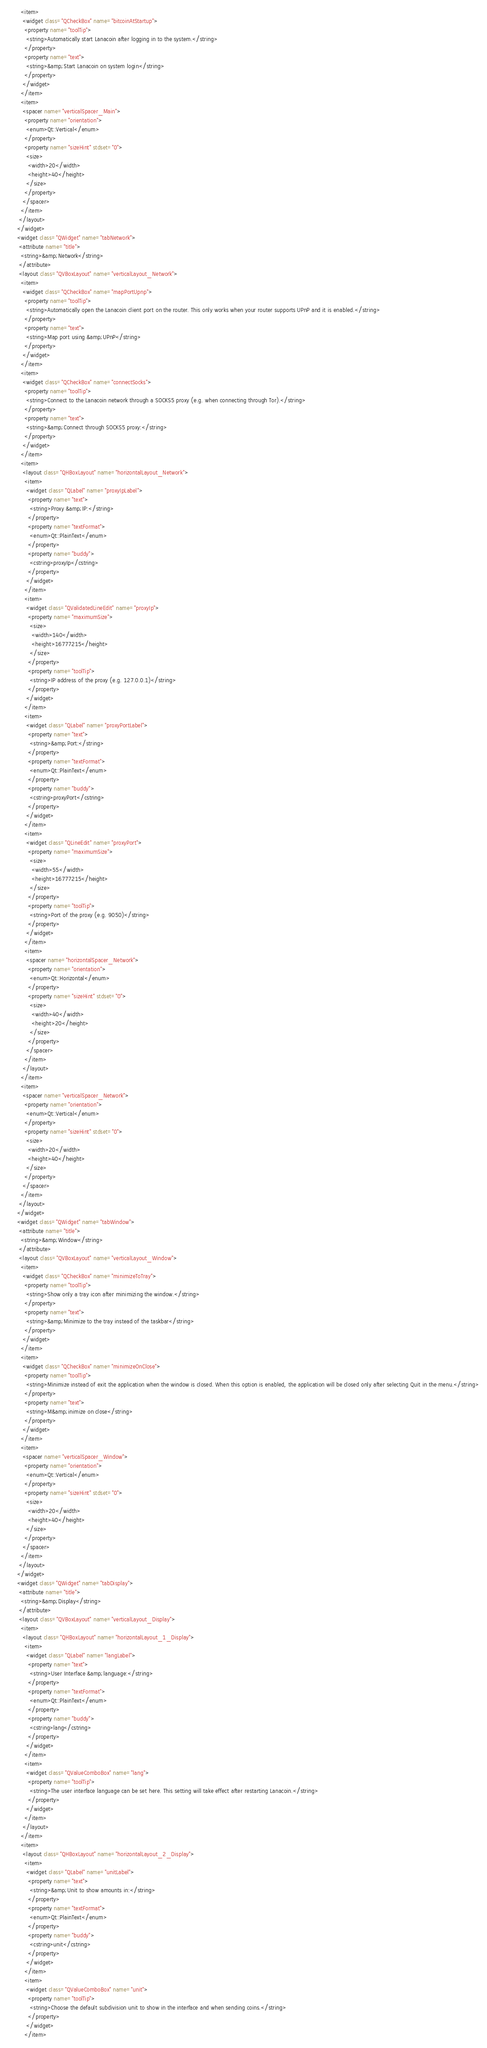<code> <loc_0><loc_0><loc_500><loc_500><_XML_>       <item>
        <widget class="QCheckBox" name="bitcoinAtStartup">
         <property name="toolTip">
          <string>Automatically start Lanacoin after logging in to the system.</string>
         </property>
         <property name="text">
          <string>&amp;Start Lanacoin on system login</string>
         </property>
        </widget>
       </item>
       <item>
        <spacer name="verticalSpacer_Main">
         <property name="orientation">
          <enum>Qt::Vertical</enum>
         </property>
         <property name="sizeHint" stdset="0">
          <size>
           <width>20</width>
           <height>40</height>
          </size>
         </property>
        </spacer>
       </item>
      </layout>
     </widget>
     <widget class="QWidget" name="tabNetwork">
      <attribute name="title">
       <string>&amp;Network</string>
      </attribute>
      <layout class="QVBoxLayout" name="verticalLayout_Network">
       <item>
        <widget class="QCheckBox" name="mapPortUpnp">
         <property name="toolTip">
          <string>Automatically open the Lanacoin client port on the router. This only works when your router supports UPnP and it is enabled.</string>
         </property>
         <property name="text">
          <string>Map port using &amp;UPnP</string>
         </property>
        </widget>
       </item>
       <item>
        <widget class="QCheckBox" name="connectSocks">
         <property name="toolTip">
          <string>Connect to the Lanacoin network through a SOCKS5 proxy (e.g. when connecting through Tor).</string>
         </property>
         <property name="text">
          <string>&amp;Connect through SOCKS5 proxy:</string>
         </property>
        </widget>
       </item>
       <item>
        <layout class="QHBoxLayout" name="horizontalLayout_Network">
         <item>
          <widget class="QLabel" name="proxyIpLabel">
           <property name="text">
            <string>Proxy &amp;IP:</string>
           </property>
           <property name="textFormat">
            <enum>Qt::PlainText</enum>
           </property>
           <property name="buddy">
            <cstring>proxyIp</cstring>
           </property>
          </widget>
         </item>
         <item>
          <widget class="QValidatedLineEdit" name="proxyIp">
           <property name="maximumSize">
            <size>
             <width>140</width>
             <height>16777215</height>
            </size>
           </property>
           <property name="toolTip">
            <string>IP address of the proxy (e.g. 127.0.0.1)</string>
           </property>
          </widget>
         </item>
         <item>
          <widget class="QLabel" name="proxyPortLabel">
           <property name="text">
            <string>&amp;Port:</string>
           </property>
           <property name="textFormat">
            <enum>Qt::PlainText</enum>
           </property>
           <property name="buddy">
            <cstring>proxyPort</cstring>
           </property>
          </widget>
         </item>
         <item>
          <widget class="QLineEdit" name="proxyPort">
           <property name="maximumSize">
            <size>
             <width>55</width>
             <height>16777215</height>
            </size>
           </property>
           <property name="toolTip">
            <string>Port of the proxy (e.g. 9050)</string>
           </property>
          </widget>
         </item>
         <item>
          <spacer name="horizontalSpacer_Network">
           <property name="orientation">
            <enum>Qt::Horizontal</enum>
           </property>
           <property name="sizeHint" stdset="0">
            <size>
             <width>40</width>
             <height>20</height>
            </size>
           </property>
          </spacer>
         </item>
        </layout>
       </item>
       <item>
        <spacer name="verticalSpacer_Network">
         <property name="orientation">
          <enum>Qt::Vertical</enum>
         </property>
         <property name="sizeHint" stdset="0">
          <size>
           <width>20</width>
           <height>40</height>
          </size>
         </property>
        </spacer>
       </item>
      </layout>
     </widget>
     <widget class="QWidget" name="tabWindow">
      <attribute name="title">
       <string>&amp;Window</string>
      </attribute>
      <layout class="QVBoxLayout" name="verticalLayout_Window">
       <item>
        <widget class="QCheckBox" name="minimizeToTray">
         <property name="toolTip">
          <string>Show only a tray icon after minimizing the window.</string>
         </property>
         <property name="text">
          <string>&amp;Minimize to the tray instead of the taskbar</string>
         </property>
        </widget>
       </item>
       <item>
        <widget class="QCheckBox" name="minimizeOnClose">
         <property name="toolTip">
          <string>Minimize instead of exit the application when the window is closed. When this option is enabled, the application will be closed only after selecting Quit in the menu.</string>
         </property>
         <property name="text">
          <string>M&amp;inimize on close</string>
         </property>
        </widget>
       </item>
       <item>
        <spacer name="verticalSpacer_Window">
         <property name="orientation">
          <enum>Qt::Vertical</enum>
         </property>
         <property name="sizeHint" stdset="0">
          <size>
           <width>20</width>
           <height>40</height>
          </size>
         </property>
        </spacer>
       </item>
      </layout>
     </widget>
     <widget class="QWidget" name="tabDisplay">
      <attribute name="title">
       <string>&amp;Display</string>
      </attribute>
      <layout class="QVBoxLayout" name="verticalLayout_Display">
       <item>
        <layout class="QHBoxLayout" name="horizontalLayout_1_Display">
         <item>
          <widget class="QLabel" name="langLabel">
           <property name="text">
            <string>User Interface &amp;language:</string>
           </property>
           <property name="textFormat">
            <enum>Qt::PlainText</enum>
           </property>
           <property name="buddy">
            <cstring>lang</cstring>
           </property>
          </widget>
         </item>
         <item>
          <widget class="QValueComboBox" name="lang">
           <property name="toolTip">
            <string>The user interface language can be set here. This setting will take effect after restarting Lanacoin.</string>
           </property>
          </widget>
         </item>
        </layout>
       </item>
       <item>
        <layout class="QHBoxLayout" name="horizontalLayout_2_Display">
         <item>
          <widget class="QLabel" name="unitLabel">
           <property name="text">
            <string>&amp;Unit to show amounts in:</string>
           </property>
           <property name="textFormat">
            <enum>Qt::PlainText</enum>
           </property>
           <property name="buddy">
            <cstring>unit</cstring>
           </property>
          </widget>
         </item>
         <item>
          <widget class="QValueComboBox" name="unit">
           <property name="toolTip">
            <string>Choose the default subdivision unit to show in the interface and when sending coins.</string>
           </property>
          </widget>
         </item></code> 